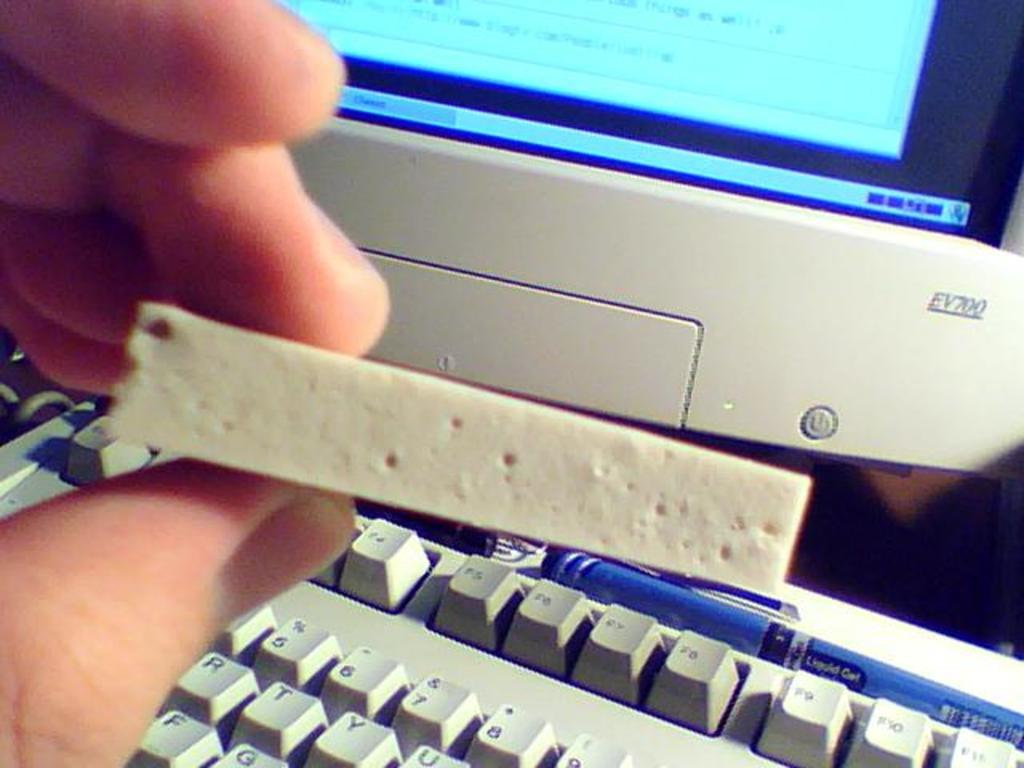<image>
Give a short and clear explanation of the subsequent image. A man is holding something in front of a EV700 computer. 